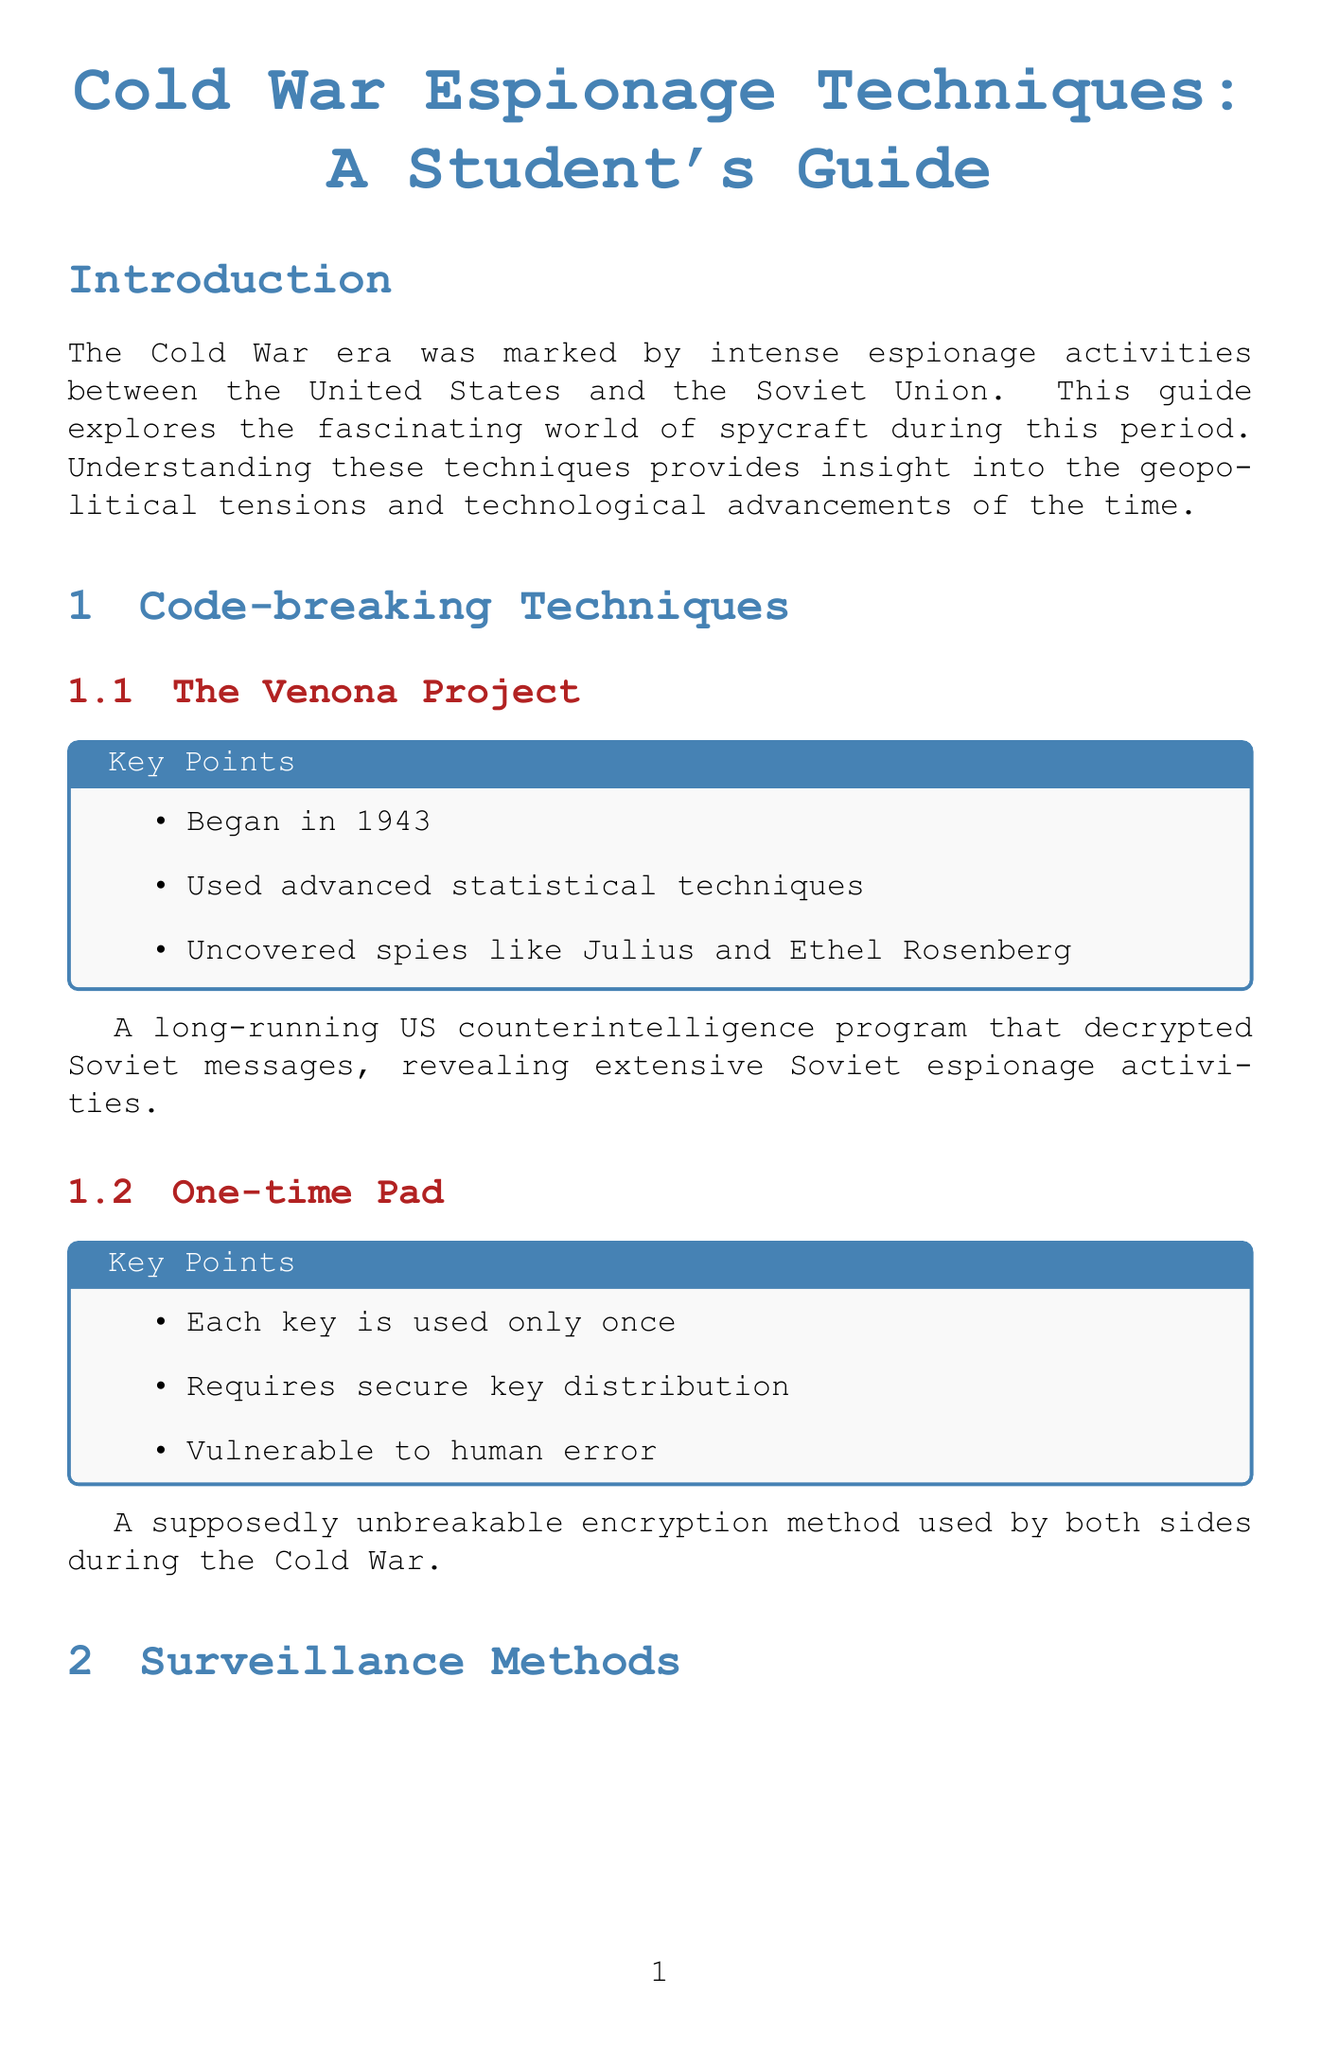What year did the Venona Project begin? The Venona Project began in 1943, as stated in the key points of the code-breaking techniques section.
Answer: 1943 What operation involved the CIA and MI6 in East Berlin? Operation Gold is a joint CIA-MI6 operation to tap Soviet communication lines in East Berlin, as described in the surveillance methods section.
Answer: Operation Gold Which key method was used by KGB agent Oleg Penkovsky? Dead Drops is the method used by KGB agent Oleg Penkovsky for covertly passing information, mentioned in the HUMINT section.
Answer: Dead Drops What was the goal of Project AZORIAN? The goal of Project AZORIAN was to recover a sunken Soviet submarine, as indicated in the technological espionage section.
Answer: Recover a sunken Soviet submarine What was deemed impractical and abandoned? Acoustic Kitty was a CIA project deemed impractical and abandoned after attempts to use cats as listening devices.
Answer: Acoustic Kitty Which famous case involved honey traps? The Profumo Affair in Britain is a famous case involving honey traps, noted in the HUMINT section.
Answer: Profumo Affair How long did Operation Gold last? Operation Gold was conducted from 1955 to 1956, according to the key points listed in the surveillance methods section.
Answer: 1955 to 1956 What deception technique raises ethical concerns and potential for blackmail? Honey Traps are the deception technique that raises ethical concerns and potential for blackmail, as mentioned in the HUMINT section.
Answer: Honey Traps What method is characterized by each key being used only once? The One-time Pad is characterized by each key being used only once, detailed in the code-breaking techniques section.
Answer: One-time Pad 